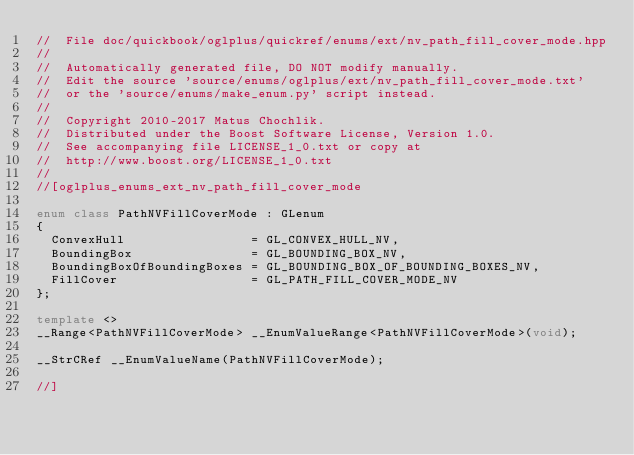Convert code to text. <code><loc_0><loc_0><loc_500><loc_500><_C++_>//  File doc/quickbook/oglplus/quickref/enums/ext/nv_path_fill_cover_mode.hpp
//
//  Automatically generated file, DO NOT modify manually.
//  Edit the source 'source/enums/oglplus/ext/nv_path_fill_cover_mode.txt'
//  or the 'source/enums/make_enum.py' script instead.
//
//  Copyright 2010-2017 Matus Chochlik.
//  Distributed under the Boost Software License, Version 1.0.
//  See accompanying file LICENSE_1_0.txt or copy at
//  http://www.boost.org/LICENSE_1_0.txt
//
//[oglplus_enums_ext_nv_path_fill_cover_mode

enum class PathNVFillCoverMode : GLenum
{
	ConvexHull                 = GL_CONVEX_HULL_NV,
	BoundingBox                = GL_BOUNDING_BOX_NV,
	BoundingBoxOfBoundingBoxes = GL_BOUNDING_BOX_OF_BOUNDING_BOXES_NV,
	FillCover                  = GL_PATH_FILL_COVER_MODE_NV
};

template <>
__Range<PathNVFillCoverMode> __EnumValueRange<PathNVFillCoverMode>(void);

__StrCRef __EnumValueName(PathNVFillCoverMode);

//]
</code> 